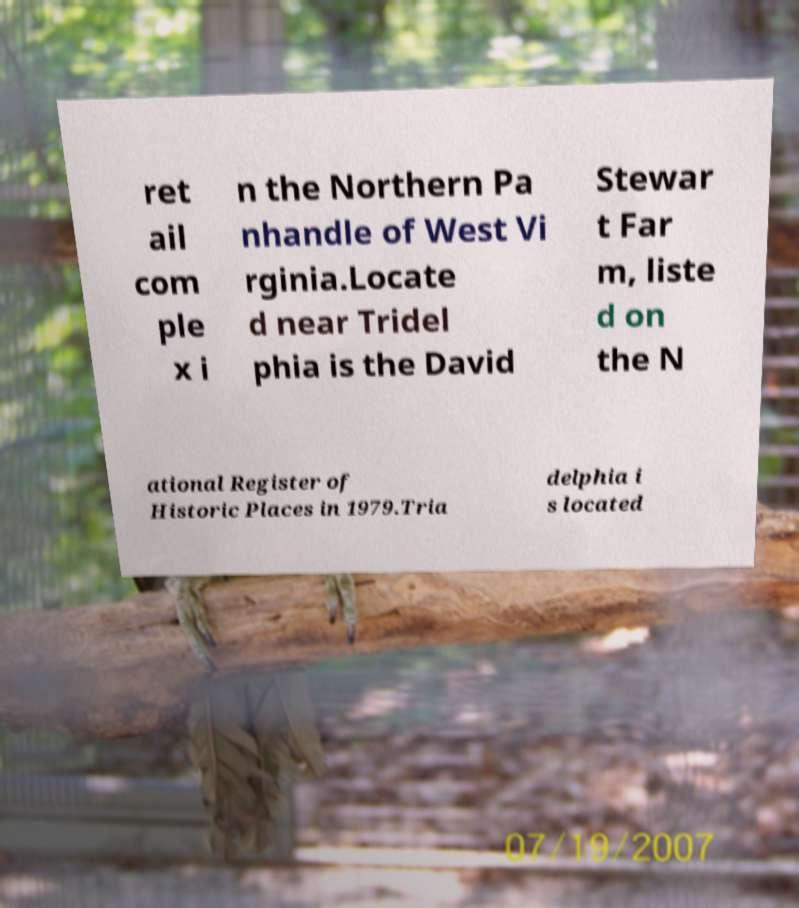Please identify and transcribe the text found in this image. ret ail com ple x i n the Northern Pa nhandle of West Vi rginia.Locate d near Tridel phia is the David Stewar t Far m, liste d on the N ational Register of Historic Places in 1979.Tria delphia i s located 